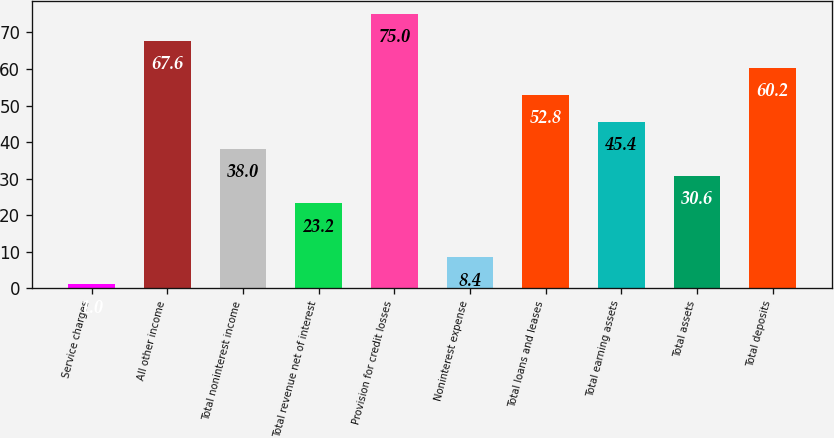<chart> <loc_0><loc_0><loc_500><loc_500><bar_chart><fcel>Service charges<fcel>All other income<fcel>Total noninterest income<fcel>Total revenue net of interest<fcel>Provision for credit losses<fcel>Noninterest expense<fcel>Total loans and leases<fcel>Total earning assets<fcel>Total assets<fcel>Total deposits<nl><fcel>1<fcel>67.6<fcel>38<fcel>23.2<fcel>75<fcel>8.4<fcel>52.8<fcel>45.4<fcel>30.6<fcel>60.2<nl></chart> 